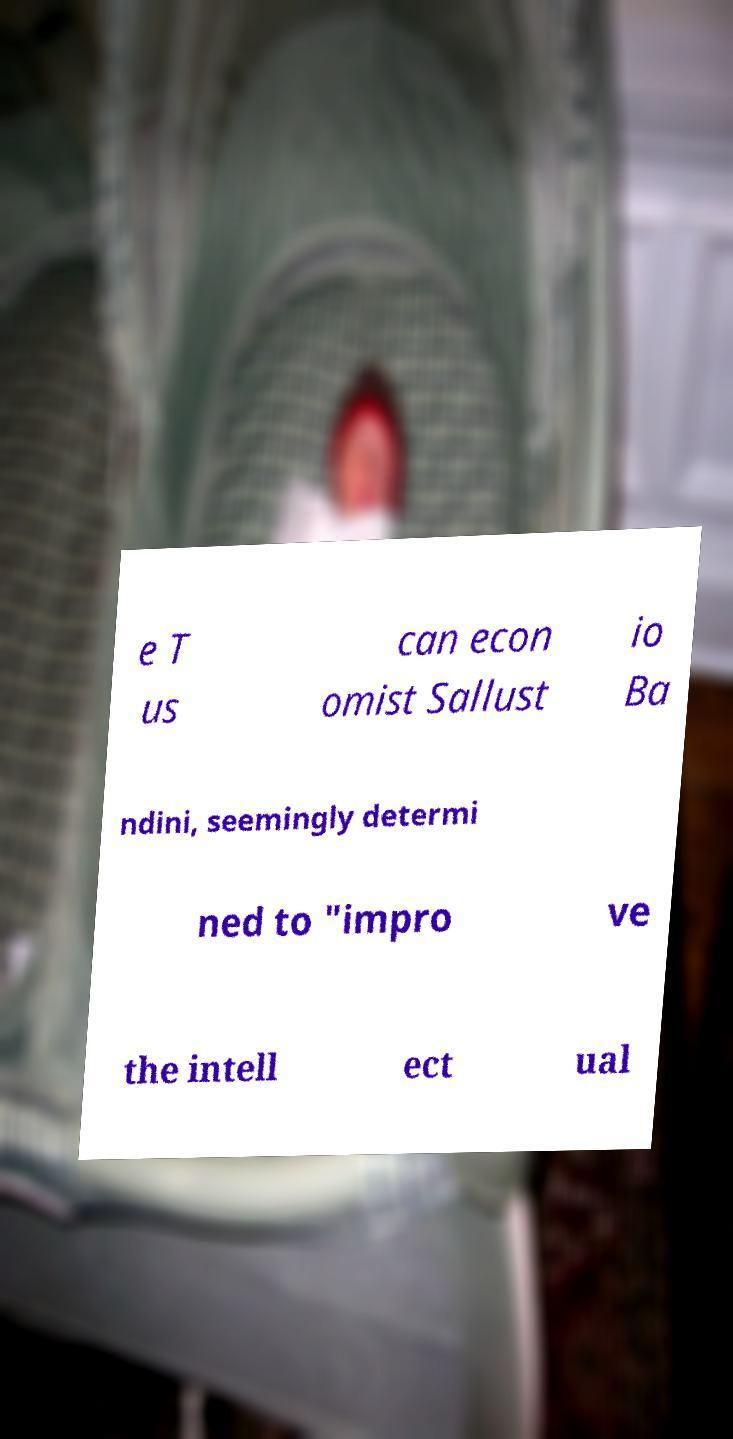Could you extract and type out the text from this image? e T us can econ omist Sallust io Ba ndini, seemingly determi ned to "impro ve the intell ect ual 